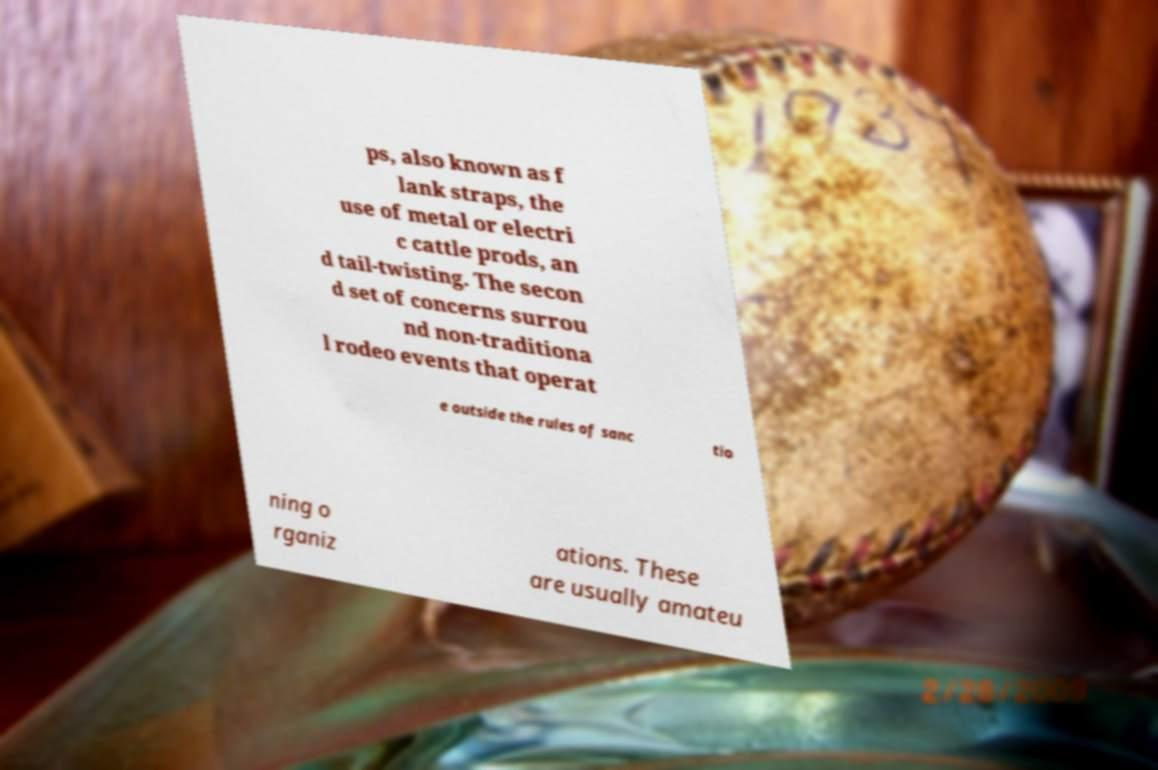I need the written content from this picture converted into text. Can you do that? ps, also known as f lank straps, the use of metal or electri c cattle prods, an d tail-twisting. The secon d set of concerns surrou nd non-traditiona l rodeo events that operat e outside the rules of sanc tio ning o rganiz ations. These are usually amateu 